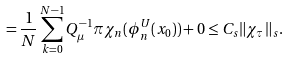Convert formula to latex. <formula><loc_0><loc_0><loc_500><loc_500>= \frac { 1 } { N } \sum _ { k = 0 } ^ { N - 1 } Q _ { \mu } ^ { - 1 } \pi \chi _ { n } ( \phi _ { n } ^ { U } ( x _ { 0 } ) ) + 0 \leq C _ { s } \| \chi _ { \tau } \| _ { s } .</formula> 